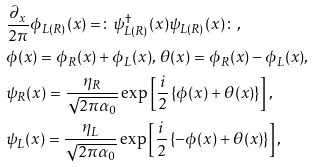<formula> <loc_0><loc_0><loc_500><loc_500>& \frac { \partial _ { x } } { 2 \pi } \phi _ { L ( R ) } ( x ) = \colon \psi _ { L ( R ) } ^ { \dagger } ( x ) \psi _ { L ( R ) } ( x ) \colon , \\ & \phi ( x ) = \phi _ { R } ( x ) + \phi _ { L } ( x ) , \, \theta ( x ) = \phi _ { R } ( x ) - \phi _ { L } ( x ) , \\ & \psi _ { R } ( x ) = \frac { \eta _ { R } } { \sqrt { 2 \pi \alpha _ { 0 } } } \exp \left [ \frac { i } { 2 } \left \{ \phi ( x ) + \theta ( x ) \right \} \right ] , \\ & \psi _ { L } ( x ) = \frac { \eta _ { L } } { \sqrt { 2 \pi \alpha _ { 0 } } } \exp \left [ \frac { i } { 2 } \left \{ - \phi ( x ) + \theta ( x ) \right \} \right ] ,</formula> 